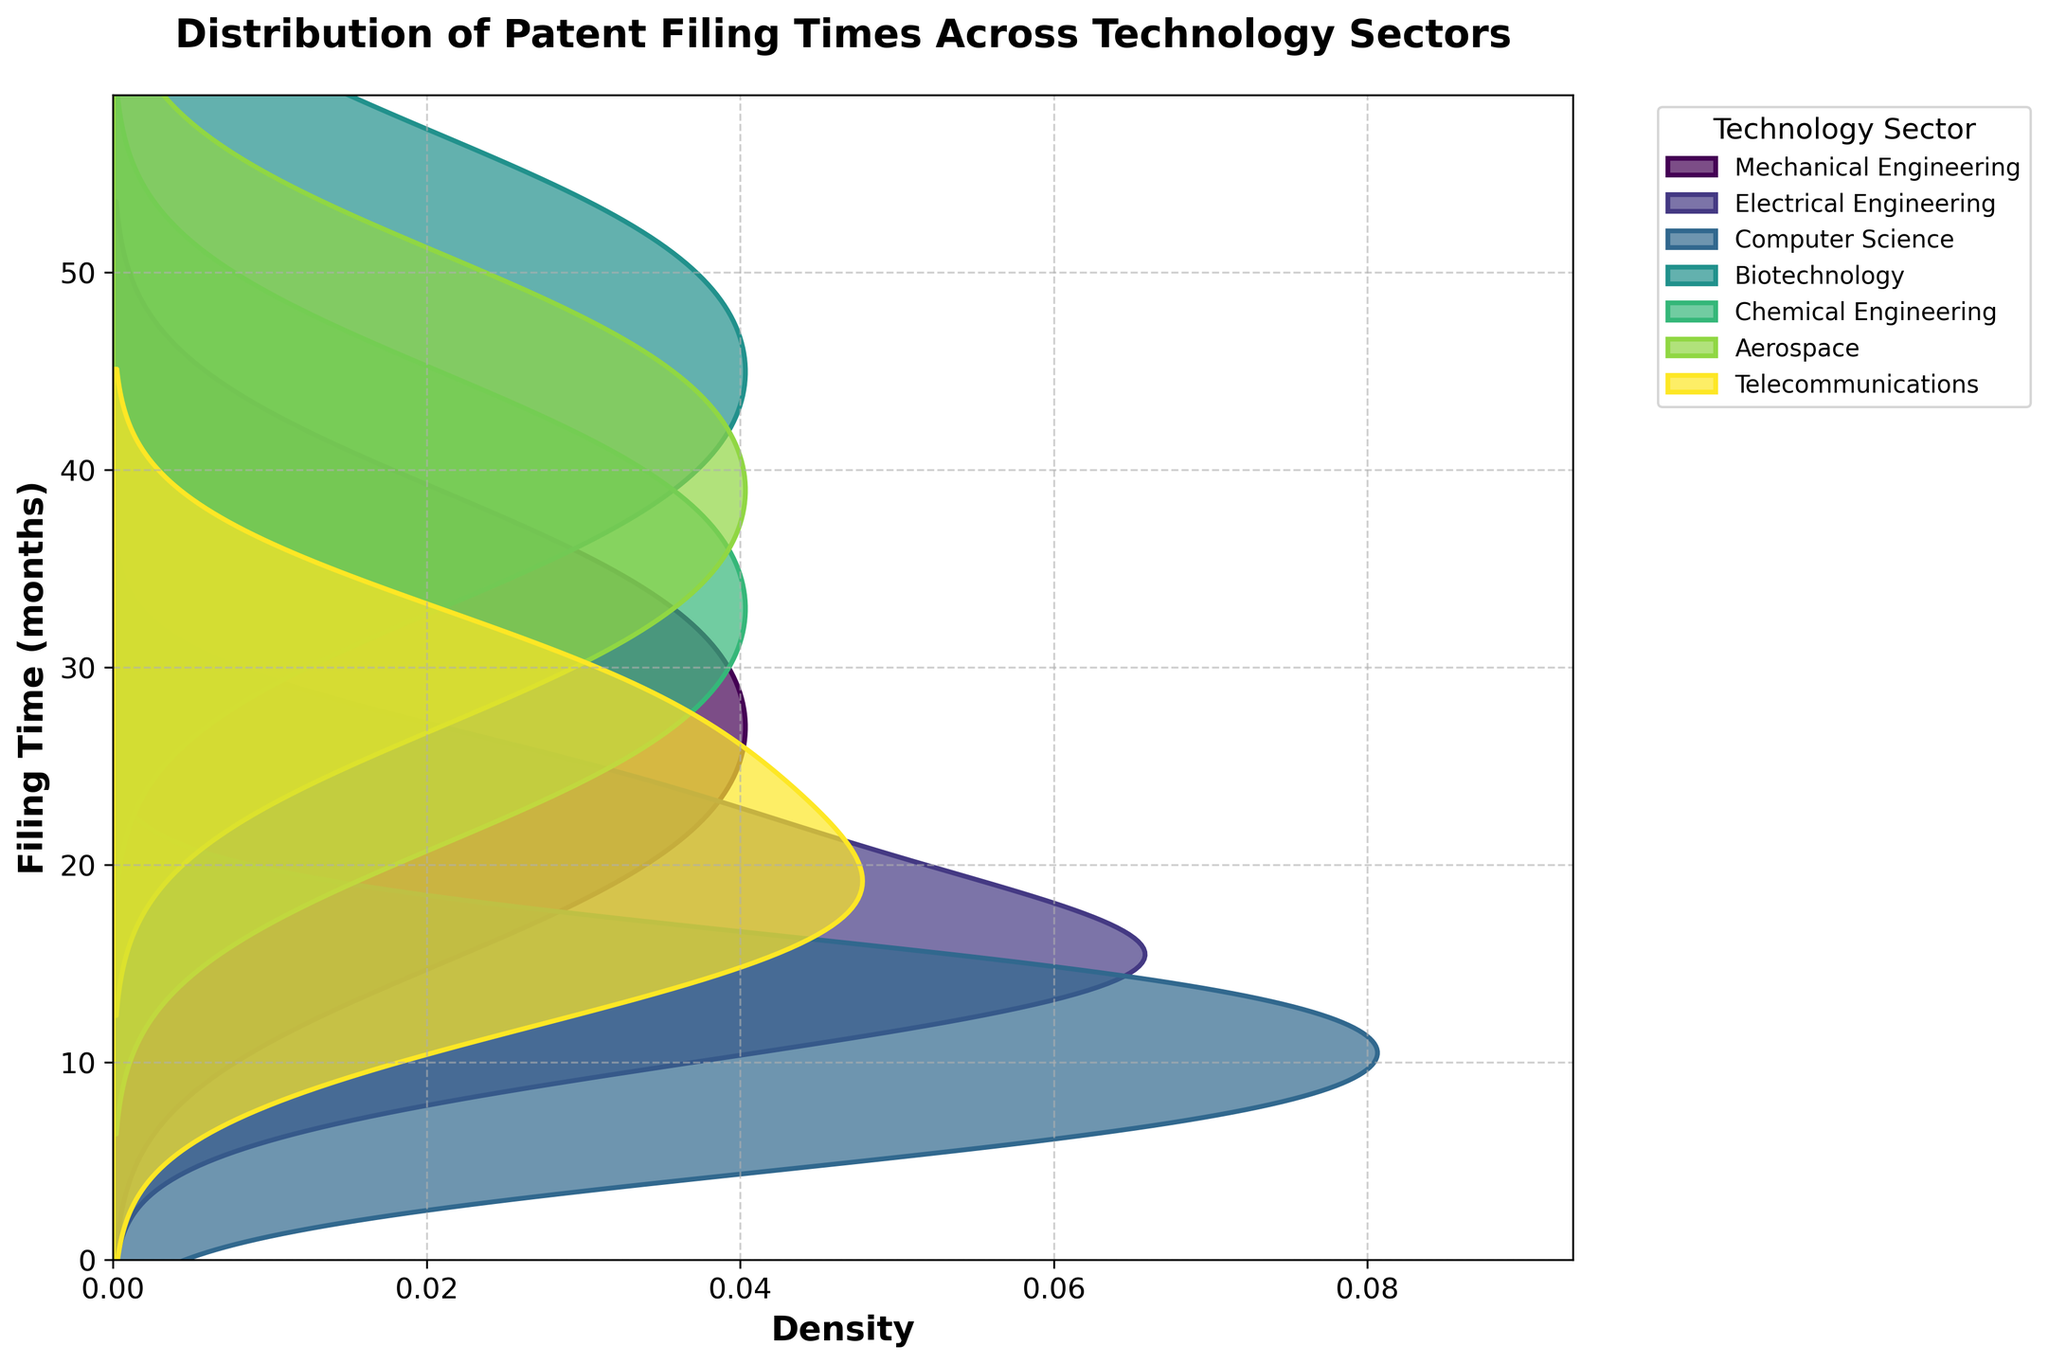How many distinct technology sectors are shown in the figure? Identify the unique sectors mentioned in the legend or the figure.
Answer: 6 What is the title of the figure? Read the text at the top of the figure that usually describes the main topic.
Answer: Distribution of Patent Filing Times Across Technology Sectors Which technology sector has the longest filing time? Look for the sector with the highest value on the vertical axis, representing filing time in months.
Answer: Biotechnology Which technology sector has the shortest filing time for patents? Locate the sector with the lowest value on the vertical axis, representing filing time in months.
Answer: Computer Science Which technology sector shows the widest distribution of filing times? Observe the sector whose density plot covers the broadest range on the vertical axis.
Answer: Biotechnology Which technology sector has peaks around 18 months? Identify the sector(s) with a high-density area near the 18-month mark on the vertical axis.
Answer: Mechanical Engineering and Telecommunications Are there any technology sectors with overlapping filing times ranges? Which ones? Compare the horizontal density plots to see if any sectors' distributions intersect.
Answer: Yes, several sectors such as Electrical Engineering and Mechanical Engineering have overlapping ranges What is the approximate range of filing times for Electrical Engineering patents? Determine the highest and lowest filing time values for the Electrical Engineering sector.
Answer: 12 to 24 months On average, do Mechanical Engineering patents take longer to file compared to Computer Science patents? Compare the central tendencies (peaks) of the distributions for these two sectors.
Answer: Yes Among Biotechnology and Aerospace, which sector has a more concentrated distribution of filing times? Assess the shape of the density plots; a taller and narrower plot indicates a more concentrated distribution.
Answer: Aerospace 